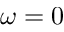<formula> <loc_0><loc_0><loc_500><loc_500>\omega = 0</formula> 